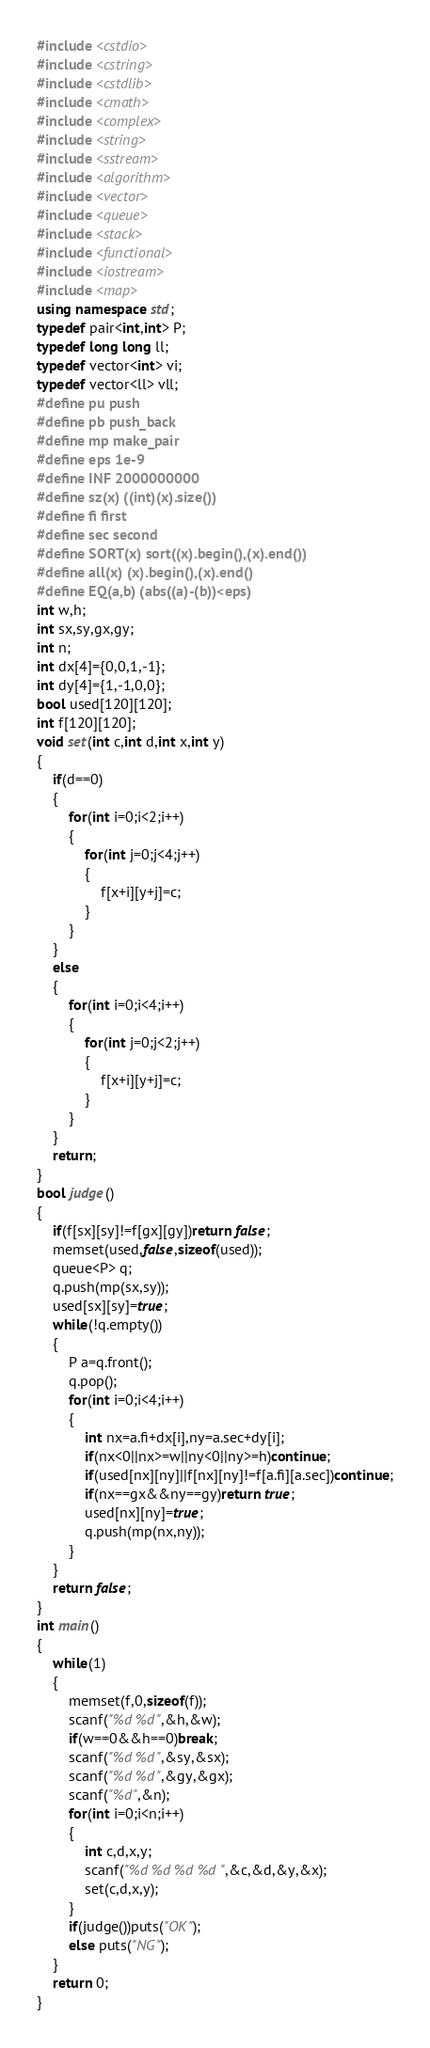<code> <loc_0><loc_0><loc_500><loc_500><_C++_>#include <cstdio>
#include <cstring>
#include <cstdlib>
#include <cmath>
#include <complex>
#include <string>
#include <sstream>
#include <algorithm>
#include <vector>
#include <queue>
#include <stack>
#include <functional>
#include <iostream>
#include <map>
using namespace std;
typedef pair<int,int> P;
typedef long long ll;
typedef vector<int> vi;
typedef vector<ll> vll;
#define pu push
#define pb push_back
#define mp make_pair
#define eps 1e-9
#define INF 2000000000
#define sz(x) ((int)(x).size())
#define fi first
#define sec second
#define SORT(x) sort((x).begin(),(x).end())
#define all(x) (x).begin(),(x).end()
#define EQ(a,b) (abs((a)-(b))<eps)
int w,h;
int sx,sy,gx,gy;
int n;
int dx[4]={0,0,1,-1};
int dy[4]={1,-1,0,0};
bool used[120][120];
int f[120][120];
void set(int c,int d,int x,int y)
{
	if(d==0)
	{
		for(int i=0;i<2;i++)
		{
			for(int j=0;j<4;j++)
			{
				f[x+i][y+j]=c;
			}
		}
	}
	else
	{
		for(int i=0;i<4;i++)
		{
			for(int j=0;j<2;j++)
			{
				f[x+i][y+j]=c;
			}
		}
	}
	return;
}
bool judge()
{
	if(f[sx][sy]!=f[gx][gy])return false;
	memset(used,false,sizeof(used));
	queue<P> q;
	q.push(mp(sx,sy));
	used[sx][sy]=true;
	while(!q.empty())
	{
		P a=q.front();
		q.pop();
		for(int i=0;i<4;i++)
		{
			int nx=a.fi+dx[i],ny=a.sec+dy[i];
			if(nx<0||nx>=w||ny<0||ny>=h)continue;
			if(used[nx][ny]||f[nx][ny]!=f[a.fi][a.sec])continue;
			if(nx==gx&&ny==gy)return true;
			used[nx][ny]=true;
			q.push(mp(nx,ny));
		}
	}
	return false;
}
int main()
{
	while(1)
	{
		memset(f,0,sizeof(f));
		scanf("%d %d",&h,&w);
		if(w==0&&h==0)break;
		scanf("%d %d",&sy,&sx);
		scanf("%d %d",&gy,&gx);
		scanf("%d",&n);
		for(int i=0;i<n;i++)
		{
			int c,d,x,y;
			scanf("%d %d %d %d",&c,&d,&y,&x);
			set(c,d,x,y);
		}
		if(judge())puts("OK");
		else puts("NG");
	}
	return 0;
}</code> 